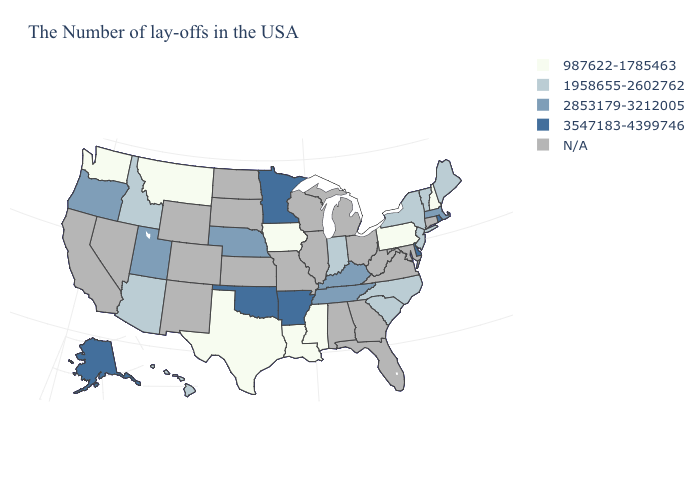Does Alaska have the highest value in the West?
Keep it brief. Yes. Which states have the lowest value in the USA?
Be succinct. New Hampshire, Pennsylvania, Mississippi, Louisiana, Iowa, Texas, Montana, Washington. Does Rhode Island have the highest value in the USA?
Quick response, please. Yes. Is the legend a continuous bar?
Answer briefly. No. Does the map have missing data?
Concise answer only. Yes. Name the states that have a value in the range 987622-1785463?
Short answer required. New Hampshire, Pennsylvania, Mississippi, Louisiana, Iowa, Texas, Montana, Washington. What is the value of Minnesota?
Be succinct. 3547183-4399746. Does Iowa have the lowest value in the MidWest?
Short answer required. Yes. Which states have the lowest value in the West?
Concise answer only. Montana, Washington. Does Texas have the highest value in the USA?
Short answer required. No. Name the states that have a value in the range 987622-1785463?
Keep it brief. New Hampshire, Pennsylvania, Mississippi, Louisiana, Iowa, Texas, Montana, Washington. What is the value of Hawaii?
Concise answer only. 1958655-2602762. Does the first symbol in the legend represent the smallest category?
Write a very short answer. Yes. What is the lowest value in states that border Massachusetts?
Be succinct. 987622-1785463. Name the states that have a value in the range 3547183-4399746?
Answer briefly. Rhode Island, Delaware, Arkansas, Minnesota, Oklahoma, Alaska. 